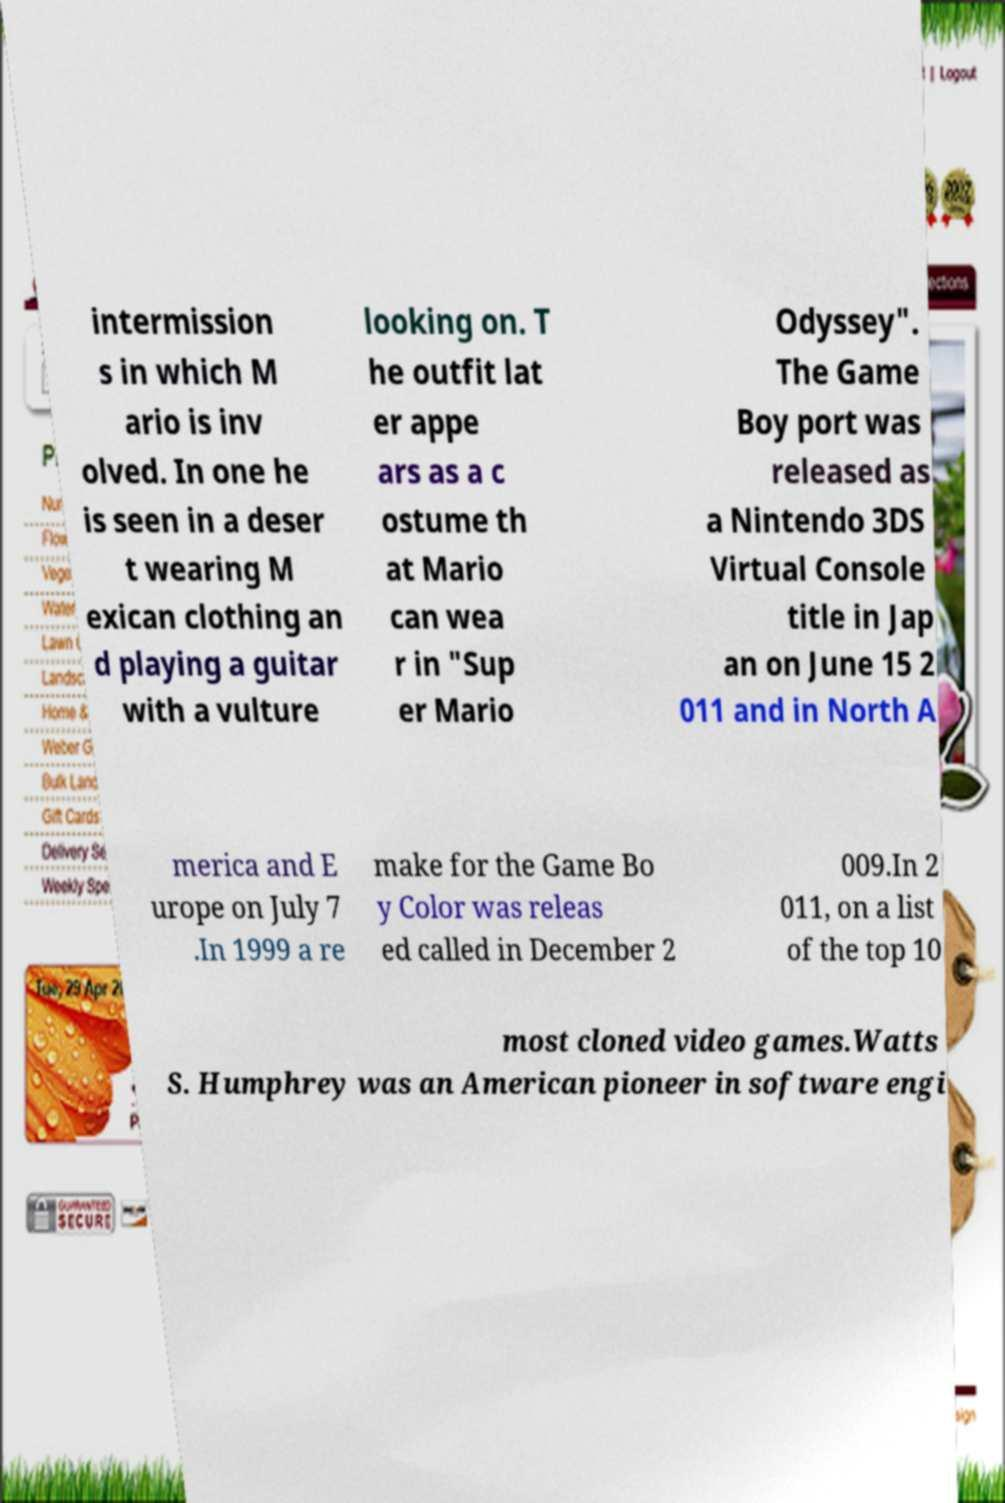Could you assist in decoding the text presented in this image and type it out clearly? intermission s in which M ario is inv olved. In one he is seen in a deser t wearing M exican clothing an d playing a guitar with a vulture looking on. T he outfit lat er appe ars as a c ostume th at Mario can wea r in "Sup er Mario Odyssey". The Game Boy port was released as a Nintendo 3DS Virtual Console title in Jap an on June 15 2 011 and in North A merica and E urope on July 7 .In 1999 a re make for the Game Bo y Color was releas ed called in December 2 009.In 2 011, on a list of the top 10 most cloned video games.Watts S. Humphrey was an American pioneer in software engi 